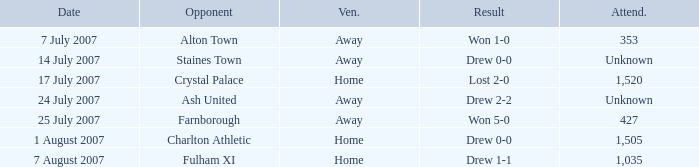Name the attendance with result of won 1-0 353.0. 